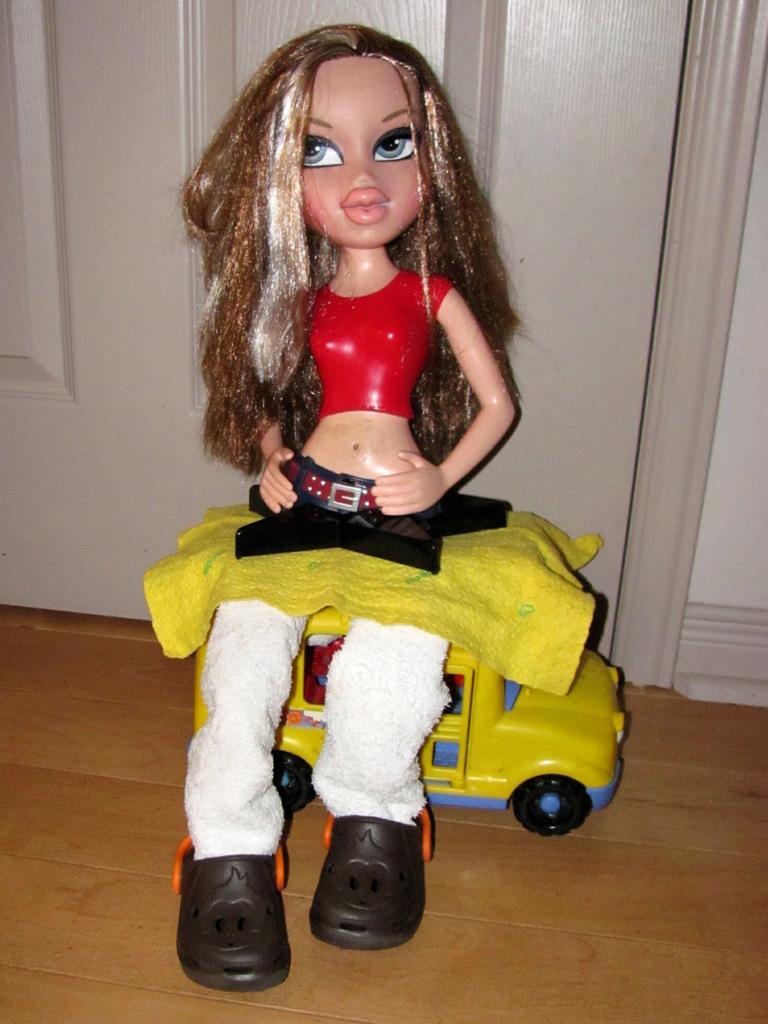How would you summarize this image in a sentence or two? In this image there is a doll and there is a toy car. In the background there is a door and there is a wall. 